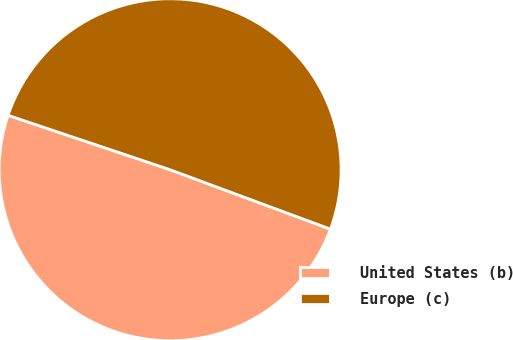Convert chart. <chart><loc_0><loc_0><loc_500><loc_500><pie_chart><fcel>United States (b)<fcel>Europe (c)<nl><fcel>49.51%<fcel>50.49%<nl></chart> 